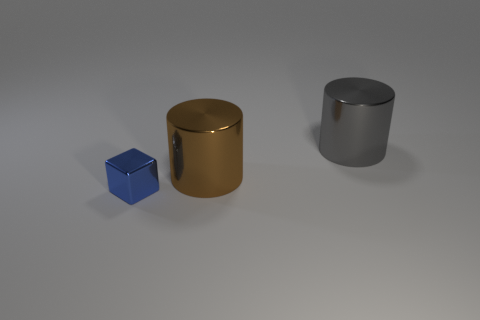Add 3 shiny objects. How many objects exist? 6 Subtract all cylinders. How many objects are left? 1 Add 2 blocks. How many blocks exist? 3 Subtract 1 blue cubes. How many objects are left? 2 Subtract all big brown rubber cylinders. Subtract all big gray metallic cylinders. How many objects are left? 2 Add 2 gray metal cylinders. How many gray metal cylinders are left? 3 